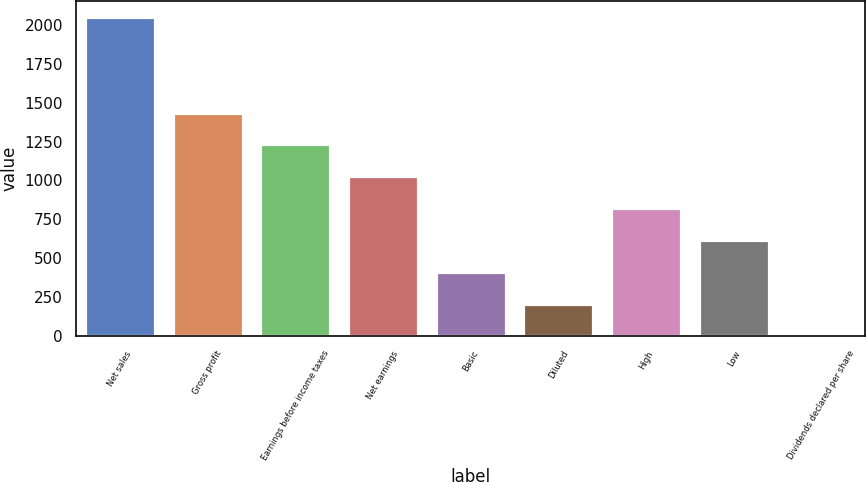Convert chart. <chart><loc_0><loc_0><loc_500><loc_500><bar_chart><fcel>Net sales<fcel>Gross profit<fcel>Earnings before income taxes<fcel>Net earnings<fcel>Basic<fcel>Diluted<fcel>High<fcel>Low<fcel>Dividends declared per share<nl><fcel>2052<fcel>1436.47<fcel>1231.29<fcel>1026.11<fcel>410.57<fcel>205.39<fcel>820.93<fcel>615.75<fcel>0.21<nl></chart> 